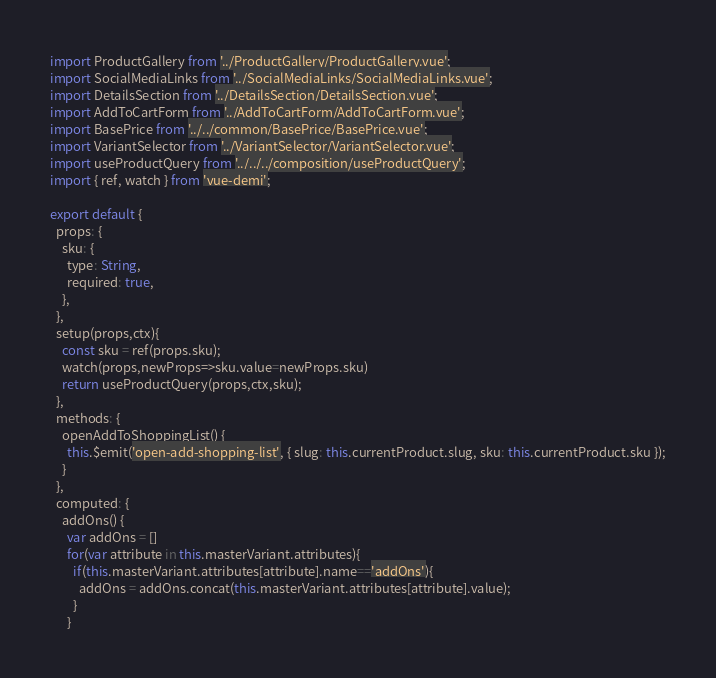<code> <loc_0><loc_0><loc_500><loc_500><_JavaScript_>import ProductGallery from '../ProductGallery/ProductGallery.vue';
import SocialMediaLinks from '../SocialMediaLinks/SocialMediaLinks.vue';
import DetailsSection from '../DetailsSection/DetailsSection.vue';
import AddToCartForm from '../AddToCartForm/AddToCartForm.vue';
import BasePrice from '../../common/BasePrice/BasePrice.vue';
import VariantSelector from '../VariantSelector/VariantSelector.vue';
import useProductQuery from '../../../composition/useProductQuery';
import { ref, watch } from 'vue-demi';

export default {
  props: {
    sku: {
      type: String,
      required: true,
    },
  },
  setup(props,ctx){
    const sku = ref(props.sku);
    watch(props,newProps=>sku.value=newProps.sku)
    return useProductQuery(props,ctx,sku);
  },
  methods: {
    openAddToShoppingList() {
      this.$emit('open-add-shopping-list', { slug: this.currentProduct.slug, sku: this.currentProduct.sku });
    }
  },
  computed: {
    addOns() {
      var addOns = []
      for(var attribute in this.masterVariant.attributes){
        if(this.masterVariant.attributes[attribute].name=='addOns'){
          addOns = addOns.concat(this.masterVariant.attributes[attribute].value);
        }
      }</code> 